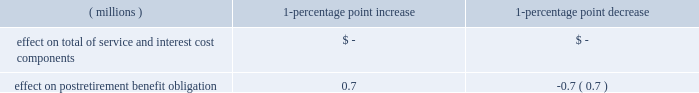At the end of 2015 , the company changed the approach used to measure service and interest costs for its u.s .
And material international pension and other postretirement benefits .
For 2016 , the company elected to measure service and interest costs by applying the specific spot rates along that yield curve to the plans 2019 liability cash flows .
The company believes this approach provides a more precise measurement of service and interest costs by aligning the timing of the plans 2019 liability cash flows to the corresponding spot rates on the yield curve .
For 2015 , the company measured service and interest costs utilizing a single weighted-average discount rate derived from the yield curve used to measure the plan obligations .
The change in approach did not affect the measurement of the company 2019s plan obligations or the funded status .
The company has accounted for this change as a change in accounting estimate and , accordingly , has accounted for it on a prospective basis .
The expected long-term rate of return used for the u.s .
Plans is based on the pension plan 2019s asset mix .
The company considers expected long-term real returns on asset categories , expectations for inflation , and estimates of the impact of active management of the assets in coming to the final rate to use .
The company also considers actual historical returns .
The expected long-term rate of return used for the company 2019s international plans is determined in each local jurisdiction and is based on the assets held in that jurisdiction , the expected rate of returns for the type of assets held and any guaranteed rate of return provided by the investment .
The other assumptions used to measure the international pension obligations , including discount rate , vary by country based on specific local requirements and information .
As previously noted , the measurement date for these plans is november 30 .
The company uses most recently available mortality tables as of the respective u.s .
And international measurement dates .
For postretirement benefit measurement purposes as of december 31 , 2016 , the annual rates of increase in the per capita cost of covered health care were assumed to be 6.75% ( 6.75 % ) for pre-65 costs and 7.25% ( 7.25 % ) for post-65 costs .
The rates are assumed to decrease each year until they reach 5% ( 5 % ) in 2023 and remain at those levels thereafter .
Health care costs for certain employees which are eligible for subsidy by the company are limited by a cap on the subsidy .
During the third quarter of 2016 , the compensation committee of the company 2019s board of directors approved moving the u.s .
Postretirement healthcare plans to a retiree exchange approach , rather than the employee group waiver plan plus wrap program , for post-65 retiree medical coverage beginning in 2018 , and the company informed all eligible legacy ecolab and legacy nalco retirees of the change .
As a result of the approval and communication to the beneficiaries , the ecolab and nalco plans were re-measured , resulting in a $ 50 million reduction of postretirement benefit obligations , with a corresponding impact to aoci of $ 31 million , net of tax .
The remeasurement was completed using discount rates of 3.29% ( 3.29 % ) and 3.60% ( 3.60 % ) , respectively .
Additionally , at the time of this remeasurement , the nalco u.s .
Postretirement health care plan was merged with the ecolab u.s .
Postretirement health care plan .
As a result of these actions , the company 2019s u.s .
Postretirement health care costs decreased by $ 5 million in 2016 .
Assumed health care cost trend rates have an effect on the amounts reported for the company 2019s u.s .
Postretirement health care benefits plan .
A one-percentage point change in the assumed health care cost trend rates would have the following effects: .
Plan asset management the company 2019s u.s .
Investment strategy and policies are designed to maximize the possibility of having sufficient funds to meet the long-term liabilities of the pension fund , while achieving a balance between the goals of asset growth of the plan and keeping risk at a reasonable level .
Current income is not a key goal of the policy .
The asset allocation position reflects the company 2019s ability and willingness to accept relatively more short-term variability in the performance of the pension plan portfolio in exchange for the expectation of better long-term returns , lower pension costs and better funded status in the long run .
The pension fund is diversified across a number of asset classes and securities .
Selected individual portfolios within the asset classes may be undiversified while maintaining the diversified nature of total plan assets .
The company has no significant concentration of risk in its u.s .
Plan assets .
Assets of funded retirement plans outside the u.s .
Are managed in each local jurisdiction and asset allocation strategy is set in accordance with local rules , regulations and practice .
Therefore , no overall target asset allocation is presented .
Although non-u.s .
Equity securities are all considered international for the company , some equity securities are considered domestic for the local plan .
The funds are invested in a variety of equities , bonds and real estate investments and , in some cases , the assets are managed by insurance companies which may offer a guaranteed rate of return .
The company has no significant concentration of risk in its international plan assets .
The fair value hierarchy is used to categorize investments measured at fair value in one of three levels in the fair value hierarchy .
This categorization is based on the observability of the inputs used in valuing the investments .
See note 7 for definitions of these levels. .
For the ecolab and nalco plan remeasurement , what percentage in the reduction of postretirement benefit obligations created a corresponding impact to aoci? 
Computations: (31 / 50)
Answer: 0.62. 